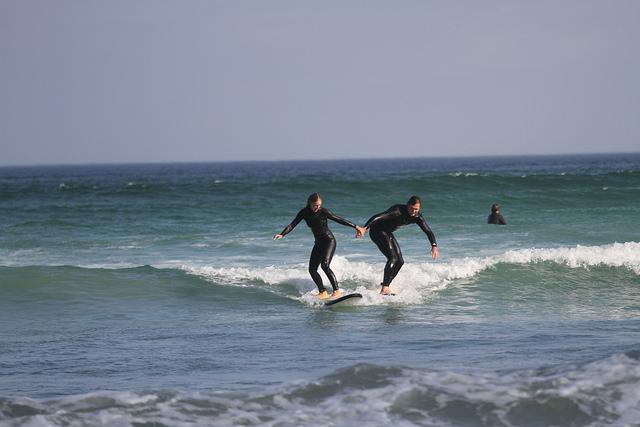Is the man helping the lady surf?
Short answer required. Yes. How many women are surfing?
Answer briefly. 2. How many people are on surfboards?
Be succinct. 2. Are the waves large?
Be succinct. No. 